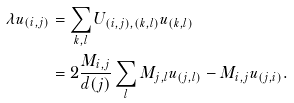Convert formula to latex. <formula><loc_0><loc_0><loc_500><loc_500>\lambda u _ { \left ( i , j \right ) } & = \sum _ { k , l } U _ { ( i , j ) , ( k , l ) } u _ { \left ( k , l \right ) } \\ & = 2 \frac { M _ { i , j } } { d ( j ) } \sum _ { l } M _ { j , l } u _ { \left ( j , l \right ) } - M _ { i , j } u _ { \left ( j , i \right ) } .</formula> 